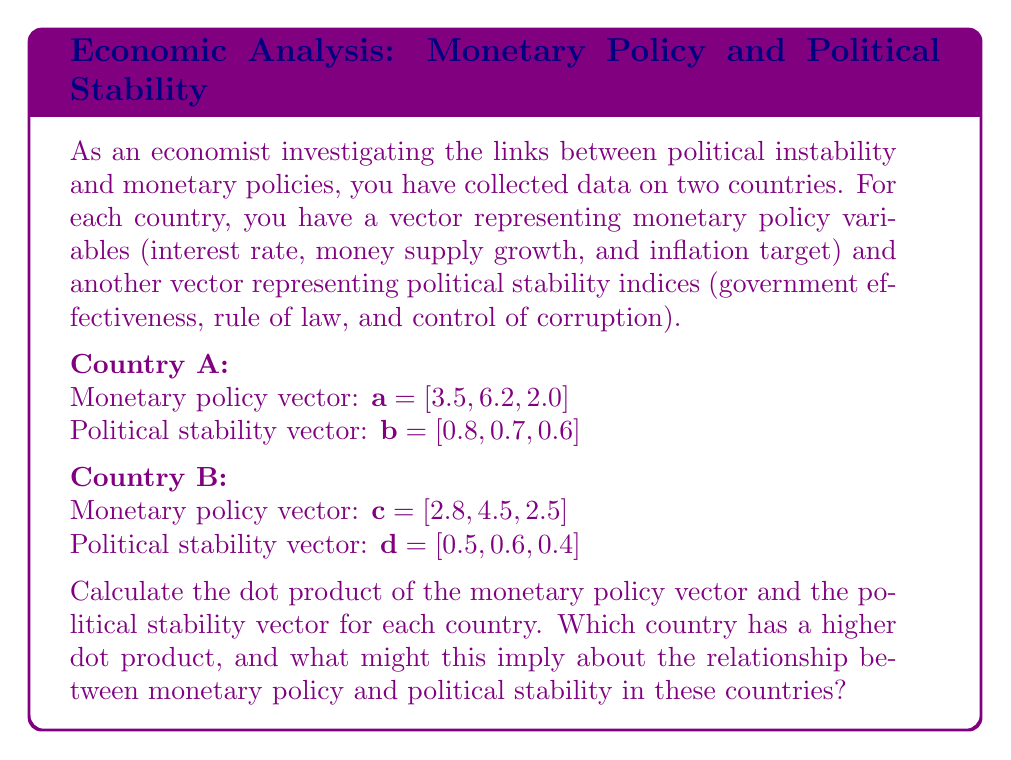Show me your answer to this math problem. Let's approach this step-by-step:

1) The dot product of two vectors $\mathbf{u} = [u_1, u_2, u_3]$ and $\mathbf{v} = [v_1, v_2, v_3]$ is given by:

   $$\mathbf{u} \cdot \mathbf{v} = u_1v_1 + u_2v_2 + u_3v_3$$

2) For Country A:
   $\mathbf{a} \cdot \mathbf{b} = (3.5 \times 0.8) + (6.2 \times 0.7) + (2.0 \times 0.6)$
   $= 2.8 + 4.34 + 1.2$
   $= 8.34$

3) For Country B:
   $\mathbf{c} \cdot \mathbf{d} = (2.8 \times 0.5) + (4.5 \times 0.6) + (2.5 \times 0.4)$
   $= 1.4 + 2.7 + 1.0$
   $= 5.1$

4) Country A has a higher dot product (8.34) compared to Country B (5.1).

5) Interpretation: A higher dot product suggests a stronger positive relationship between monetary policy variables and political stability indices. This could imply that in Country A, monetary policies are more aligned with or responsive to political stability factors compared to Country B. Alternatively, it could mean that political stability in Country A is more conducive to the implementation of certain monetary policies.
Answer: Country A: 8.34; Country B: 5.1. Country A has a higher dot product, suggesting a stronger relationship between monetary policy and political stability. 